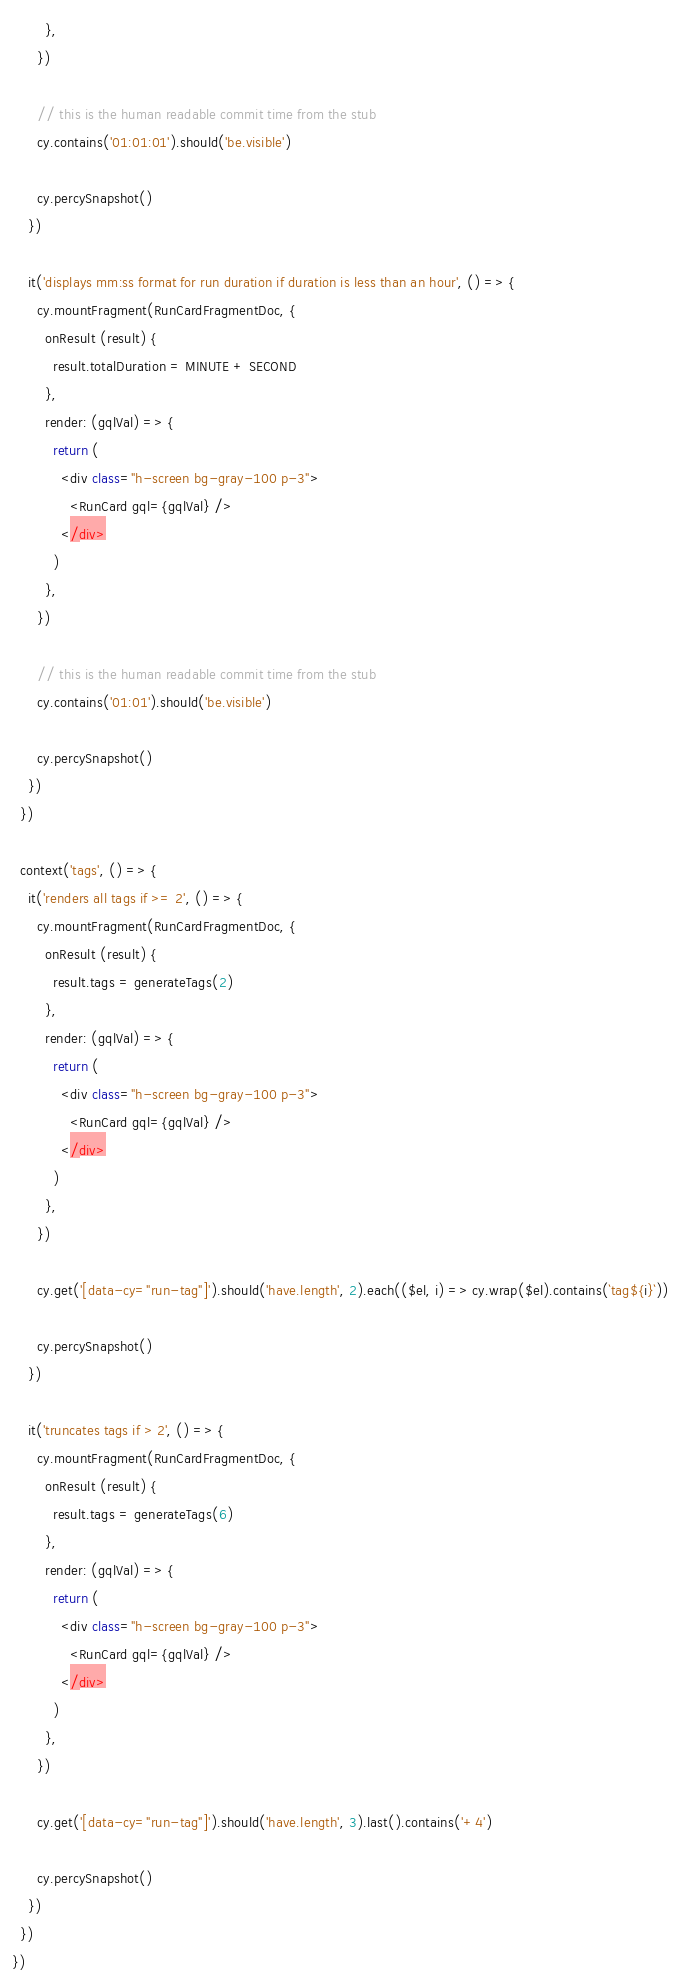Convert code to text. <code><loc_0><loc_0><loc_500><loc_500><_TypeScript_>        },
      })

      // this is the human readable commit time from the stub
      cy.contains('01:01:01').should('be.visible')

      cy.percySnapshot()
    })

    it('displays mm:ss format for run duration if duration is less than an hour', () => {
      cy.mountFragment(RunCardFragmentDoc, {
        onResult (result) {
          result.totalDuration = MINUTE + SECOND
        },
        render: (gqlVal) => {
          return (
            <div class="h-screen bg-gray-100 p-3">
              <RunCard gql={gqlVal} />
            </div>
          )
        },
      })

      // this is the human readable commit time from the stub
      cy.contains('01:01').should('be.visible')

      cy.percySnapshot()
    })
  })

  context('tags', () => {
    it('renders all tags if >= 2', () => {
      cy.mountFragment(RunCardFragmentDoc, {
        onResult (result) {
          result.tags = generateTags(2)
        },
        render: (gqlVal) => {
          return (
            <div class="h-screen bg-gray-100 p-3">
              <RunCard gql={gqlVal} />
            </div>
          )
        },
      })

      cy.get('[data-cy="run-tag"]').should('have.length', 2).each(($el, i) => cy.wrap($el).contains(`tag${i}`))

      cy.percySnapshot()
    })

    it('truncates tags if > 2', () => {
      cy.mountFragment(RunCardFragmentDoc, {
        onResult (result) {
          result.tags = generateTags(6)
        },
        render: (gqlVal) => {
          return (
            <div class="h-screen bg-gray-100 p-3">
              <RunCard gql={gqlVal} />
            </div>
          )
        },
      })

      cy.get('[data-cy="run-tag"]').should('have.length', 3).last().contains('+4')

      cy.percySnapshot()
    })
  })
})
</code> 